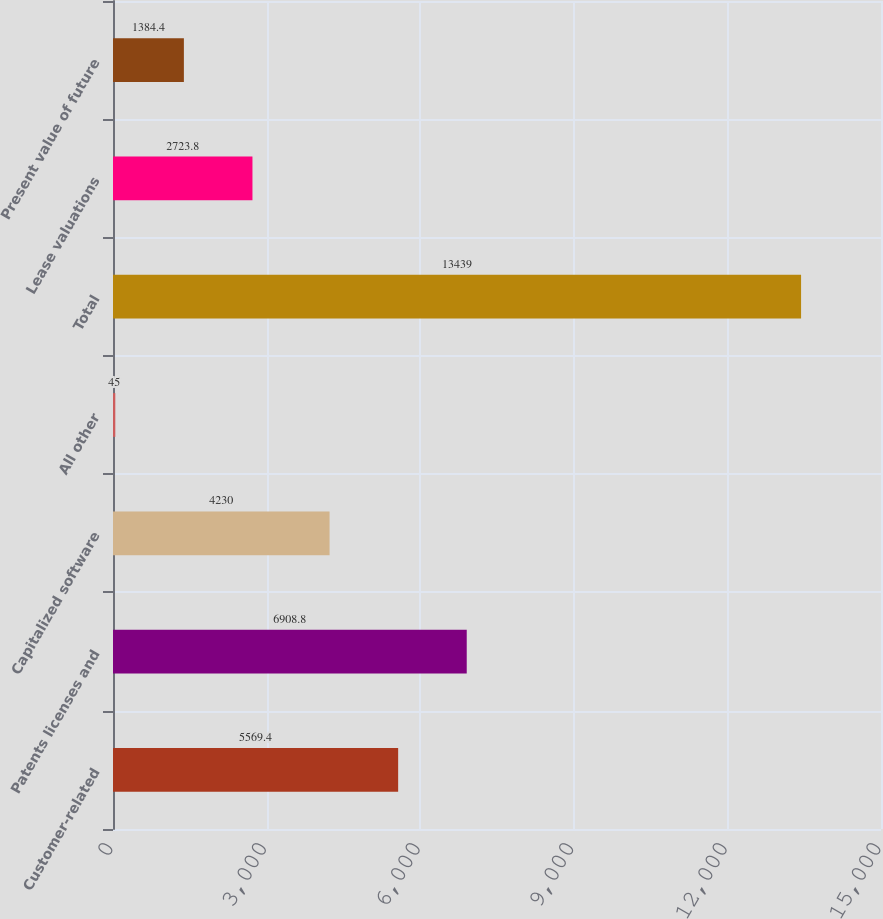<chart> <loc_0><loc_0><loc_500><loc_500><bar_chart><fcel>Customer-related<fcel>Patents licenses and<fcel>Capitalized software<fcel>All other<fcel>Total<fcel>Lease valuations<fcel>Present value of future<nl><fcel>5569.4<fcel>6908.8<fcel>4230<fcel>45<fcel>13439<fcel>2723.8<fcel>1384.4<nl></chart> 